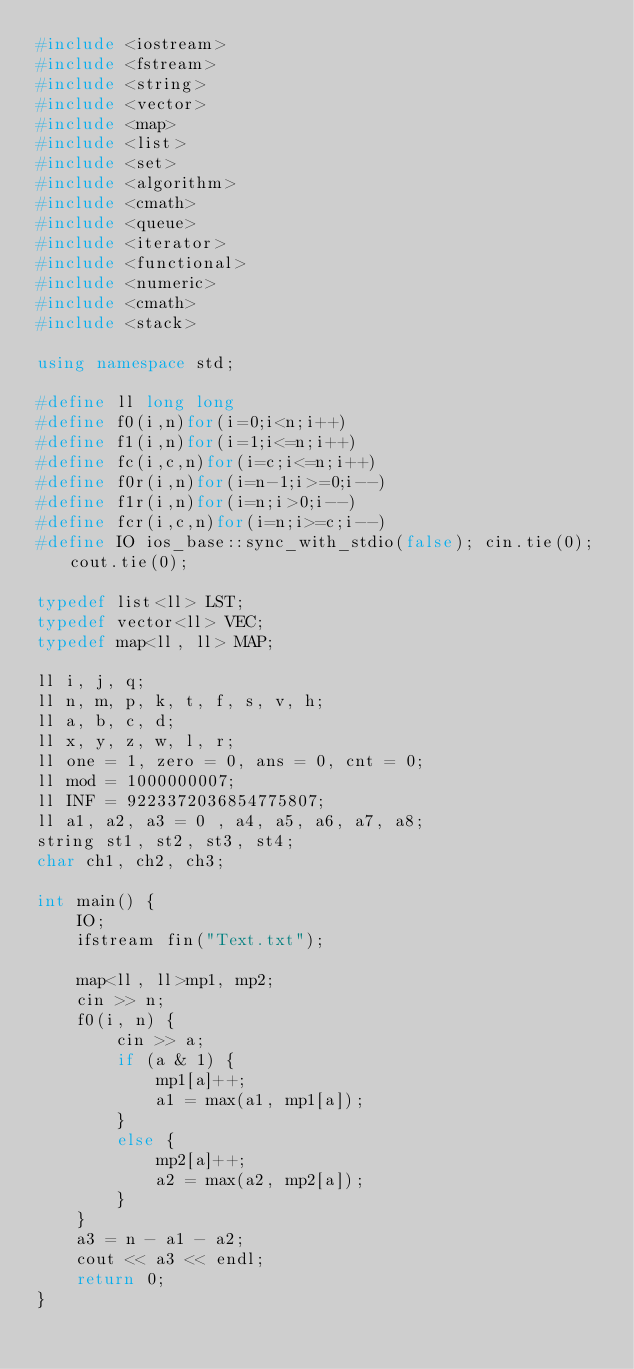Convert code to text. <code><loc_0><loc_0><loc_500><loc_500><_C++_>#include <iostream>
#include <fstream>
#include <string>
#include <vector>
#include <map>
#include <list>
#include <set>
#include <algorithm>
#include <cmath>
#include <queue>
#include <iterator>
#include <functional>
#include <numeric>
#include <cmath>
#include <stack>

using namespace std;

#define ll long long
#define f0(i,n)for(i=0;i<n;i++)
#define f1(i,n)for(i=1;i<=n;i++)
#define fc(i,c,n)for(i=c;i<=n;i++)
#define f0r(i,n)for(i=n-1;i>=0;i--)
#define f1r(i,n)for(i=n;i>0;i--)
#define fcr(i,c,n)for(i=n;i>=c;i--)
#define IO ios_base::sync_with_stdio(false); cin.tie(0); cout.tie(0);

typedef list<ll> LST;
typedef vector<ll> VEC;
typedef map<ll, ll> MAP;

ll i, j, q;
ll n, m, p, k, t, f, s, v, h;
ll a, b, c, d;
ll x, y, z, w, l, r;
ll one = 1, zero = 0, ans = 0, cnt = 0;
ll mod = 1000000007;
ll INF = 9223372036854775807;
ll a1, a2, a3 = 0 , a4, a5, a6, a7, a8;
string st1, st2, st3, st4;
char ch1, ch2, ch3;

int main() {
	IO;
	ifstream fin("Text.txt");
	
	map<ll, ll>mp1, mp2;
	cin >> n;
	f0(i, n) {
		cin >> a;
		if (a & 1) {
			mp1[a]++;
			a1 = max(a1, mp1[a]);
		}
		else {
			mp2[a]++;
			a2 = max(a2, mp2[a]);
		}
	}
	a3 = n - a1 - a2;
	cout << a3 << endl;
	return 0;
}</code> 